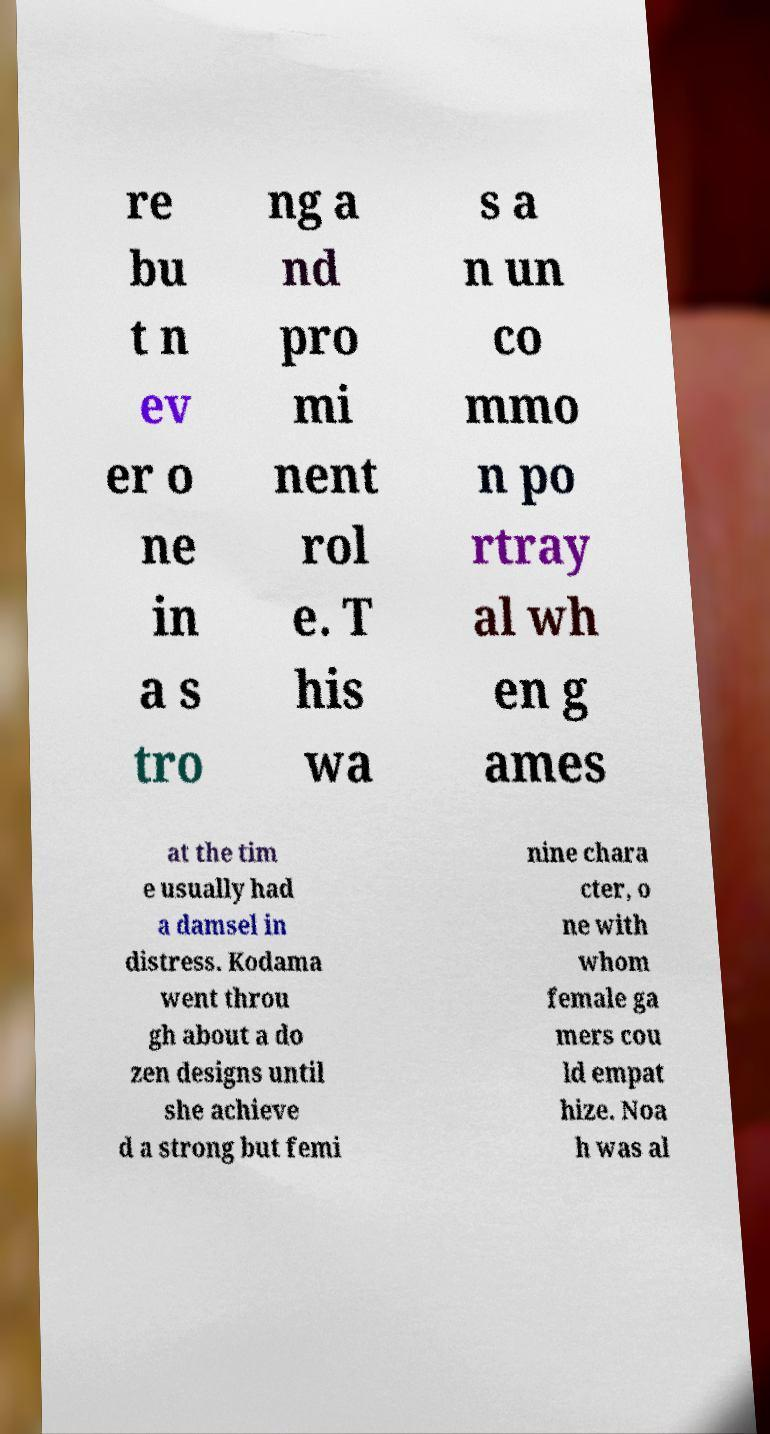Please read and relay the text visible in this image. What does it say? re bu t n ev er o ne in a s tro ng a nd pro mi nent rol e. T his wa s a n un co mmo n po rtray al wh en g ames at the tim e usually had a damsel in distress. Kodama went throu gh about a do zen designs until she achieve d a strong but femi nine chara cter, o ne with whom female ga mers cou ld empat hize. Noa h was al 